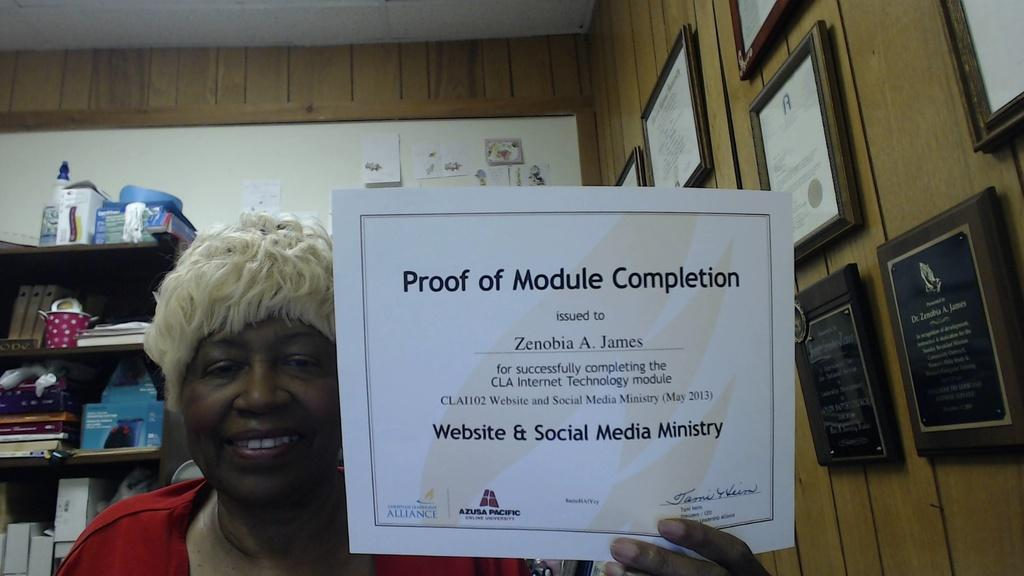Provide a one-sentence caption for the provided image. a woman holding up a certificate that says 'proof of module completion'. 